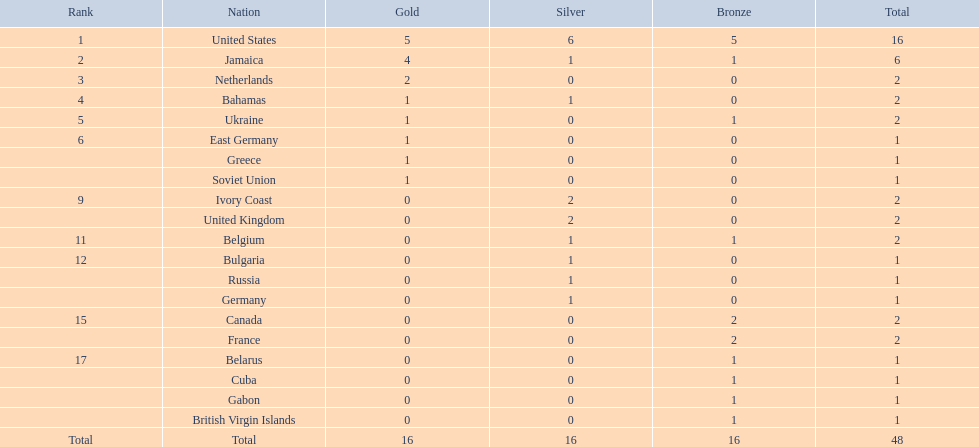What is the cumulative number of gold medals that jamaica has achieved? 4. 